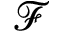Convert formula to latex. <formula><loc_0><loc_0><loc_500><loc_500>\mathcal { F }</formula> 